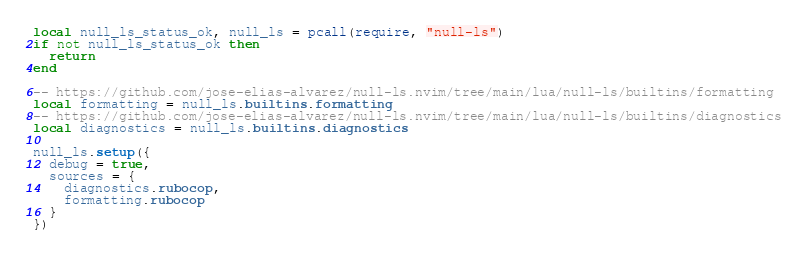<code> <loc_0><loc_0><loc_500><loc_500><_Lua_>local null_ls_status_ok, null_ls = pcall(require, "null-ls")
if not null_ls_status_ok then
  return
end

-- https://github.com/jose-elias-alvarez/null-ls.nvim/tree/main/lua/null-ls/builtins/formatting
local formatting = null_ls.builtins.formatting
-- https://github.com/jose-elias-alvarez/null-ls.nvim/tree/main/lua/null-ls/builtins/diagnostics
local diagnostics = null_ls.builtins.diagnostics

null_ls.setup({
  debug = true,
  sources = {
    diagnostics.rubocop,
    formatting.rubocop
  }
})
</code> 